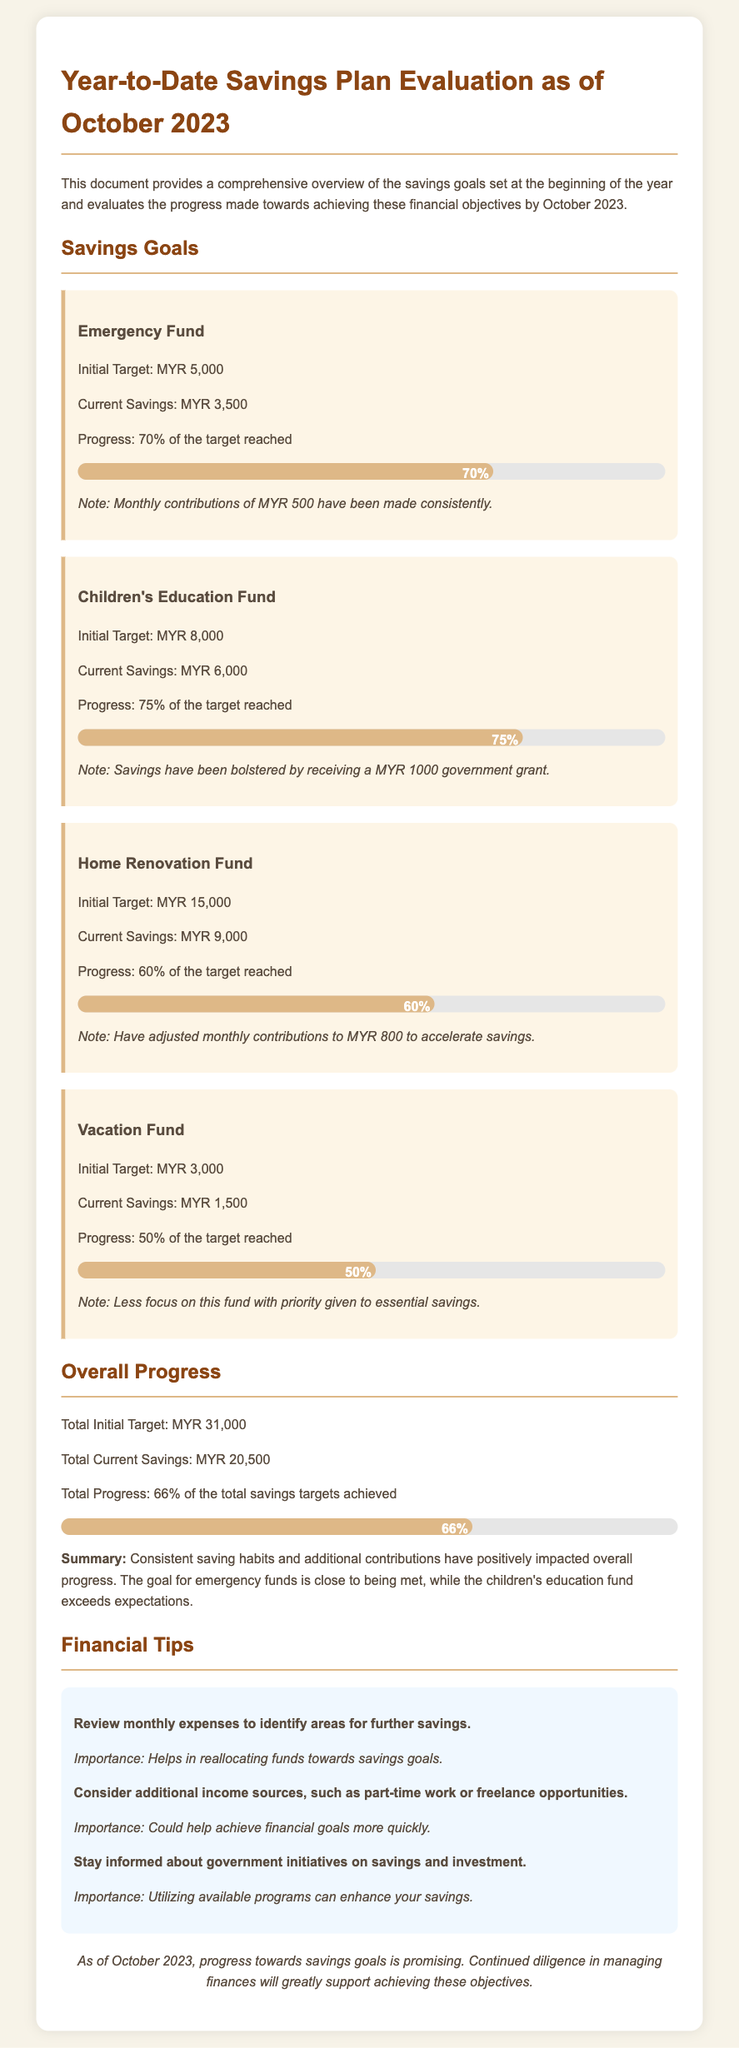What is the initial target for the Emergency Fund? The initial target for the Emergency Fund is specified in the document.
Answer: MYR 5,000 What percentage of the Children's Education Fund target has been reached? The document provides specific progress towards each savings goal.
Answer: 75% What is the current savings for the Home Renovation Fund? The current savings amount for the Home Renovation Fund is stated in the document.
Answer: MYR 9,000 What is the total initial target for all savings goals combined? The total initial target is the sum of all individual targets in the document.
Answer: MYR 31,000 What additional source helped bolster savings for the Children's Education Fund? The document mentions an additional source that contributed to this fund.
Answer: MYR 1000 government grant What is the progress percentage towards the overall savings targets? The document consolidates the progress across all savings goals into an overall percentage.
Answer: 66% What was the adjusted monthly contribution for the Home Renovation Fund? The document notes a specific adjustment to monthly contributions for this fund.
Answer: MYR 800 Which fund has the lowest current savings progress percentage? The document lists each fund's progress and allows identification of the lowest.
Answer: Vacation Fund What is the conclusion regarding overall progress towards savings goals as of October 2023? The conclusion summarizes the overall status in the document.
Answer: Promising 